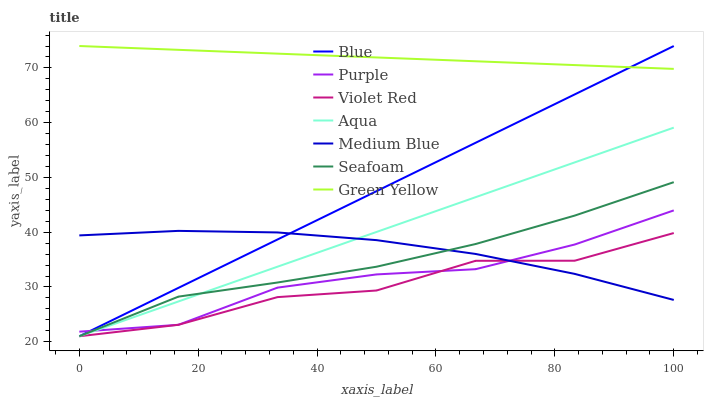Does Violet Red have the minimum area under the curve?
Answer yes or no. Yes. Does Green Yellow have the maximum area under the curve?
Answer yes or no. Yes. Does Purple have the minimum area under the curve?
Answer yes or no. No. Does Purple have the maximum area under the curve?
Answer yes or no. No. Is Blue the smoothest?
Answer yes or no. Yes. Is Violet Red the roughest?
Answer yes or no. Yes. Is Purple the smoothest?
Answer yes or no. No. Is Purple the roughest?
Answer yes or no. No. Does Blue have the lowest value?
Answer yes or no. Yes. Does Purple have the lowest value?
Answer yes or no. No. Does Green Yellow have the highest value?
Answer yes or no. Yes. Does Purple have the highest value?
Answer yes or no. No. Is Medium Blue less than Green Yellow?
Answer yes or no. Yes. Is Green Yellow greater than Purple?
Answer yes or no. Yes. Does Medium Blue intersect Purple?
Answer yes or no. Yes. Is Medium Blue less than Purple?
Answer yes or no. No. Is Medium Blue greater than Purple?
Answer yes or no. No. Does Medium Blue intersect Green Yellow?
Answer yes or no. No. 